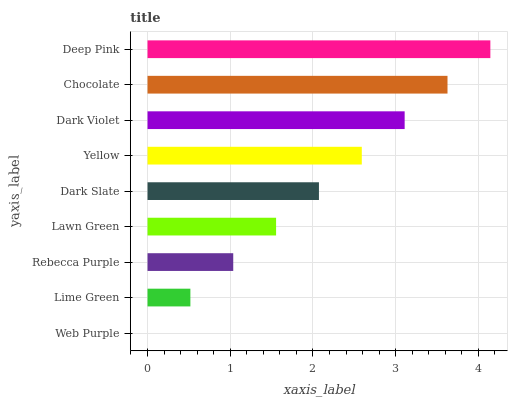Is Web Purple the minimum?
Answer yes or no. Yes. Is Deep Pink the maximum?
Answer yes or no. Yes. Is Lime Green the minimum?
Answer yes or no. No. Is Lime Green the maximum?
Answer yes or no. No. Is Lime Green greater than Web Purple?
Answer yes or no. Yes. Is Web Purple less than Lime Green?
Answer yes or no. Yes. Is Web Purple greater than Lime Green?
Answer yes or no. No. Is Lime Green less than Web Purple?
Answer yes or no. No. Is Dark Slate the high median?
Answer yes or no. Yes. Is Dark Slate the low median?
Answer yes or no. Yes. Is Lawn Green the high median?
Answer yes or no. No. Is Lime Green the low median?
Answer yes or no. No. 